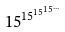Convert formula to latex. <formula><loc_0><loc_0><loc_500><loc_500>1 5 ^ { 1 5 ^ { 1 5 ^ { 1 5 ^ { \dots } } } }</formula> 